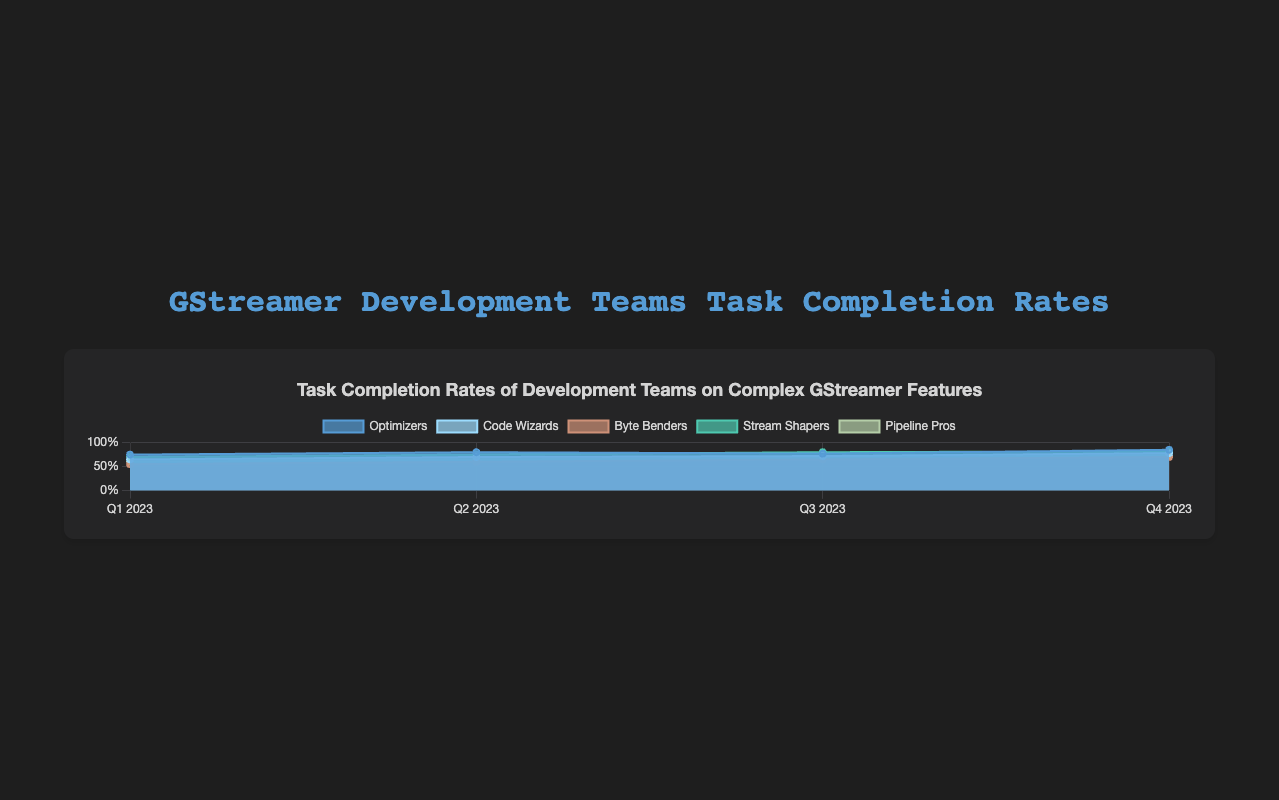What is the title of the chart? The title of the chart is located at the top and usually summarizes the main idea being conveyed. In this case, the title is "Task Completion Rates of Development Teams on Complex GStreamer Features".
Answer: Task Completion Rates of Development Teams on Complex GStreamer Features Which team had the highest completion rate in Q4 2023? To determine the highest completion rate for Q4 2023, observe the values for each team's completion rate in that quarter. "Optimizers" had a completion rate of 85%, which is the highest.
Answer: Optimizers What is the average task completion rate for the "Code Wizards" across all quarters? To find the average, sum up all the quarterly completion rates for "Code Wizards" (65 + 70 + 72 + 78) = 285, then divide by the number of quarters (4). Thus, the average is 285/4 = 71.25%.
Answer: 71.25% How does "Byte Benders"' completion rate in Q3 2023 compare to Q4 2023? Reviewing the values for "Byte Benders", in Q3 2023 their completion rate was 65%, while in Q4 2023 it was 70%. This indicates an increase of 5 percentage points.
Answer: Increased by 5% Which quarter had the lowest completion rate for the "Stream Shapers"? Inspecting the quarterly values for "Stream Shapers", we see Q1 2023 had the lowest completion rate at 70%.
Answer: Q1 2023 By how much did the "Pipeline Pros" improve from Q1 to Q4 2023? The improvement can be calculated by subtracting the Q1 2023 completion rate from the Q4 2023 completion rate for "Pipeline Pros" (73% - 60%) = 13%.
Answer: 13% Which team showed the least variation in their task completion rates over the quarters? Variation can be assessed by comparing the difference between the highest and lowest completion rates for each team. "Stream Shapers" ranged from 70% to 82%, showing the least variation (12 percentage points).
Answer: Stream Shapers What trend do we observe for the "Optimizers" across the quarters? Analyzing the completion rates for the "Optimizers", we observe a general upward trend from 75% in Q1 to 85% in Q4, with minor fluctuations in between.
Answer: Upward trend Which team had the most significant increase in task completion rate between any two consecutive quarters, and what was the increase? Looking at the quarter-to-quarter changes for all teams, "Stream Shapers" increased by 5 percentage points from Q1 to Q2 (70% to 75%), which is the highest consecutive quarterly increase in this dataset.
Answer: Stream Shapers, 5% What is the median completion rate of all teams in Q2 2023? To find the median, list the completion rates for Q2: 80%, 70%, 60%, 75%, 65%. Sorting them gives 60%, 65%, 70%, 75%, 80%. The median value is the middle number in this sorted list, which is 70%.
Answer: 70% 